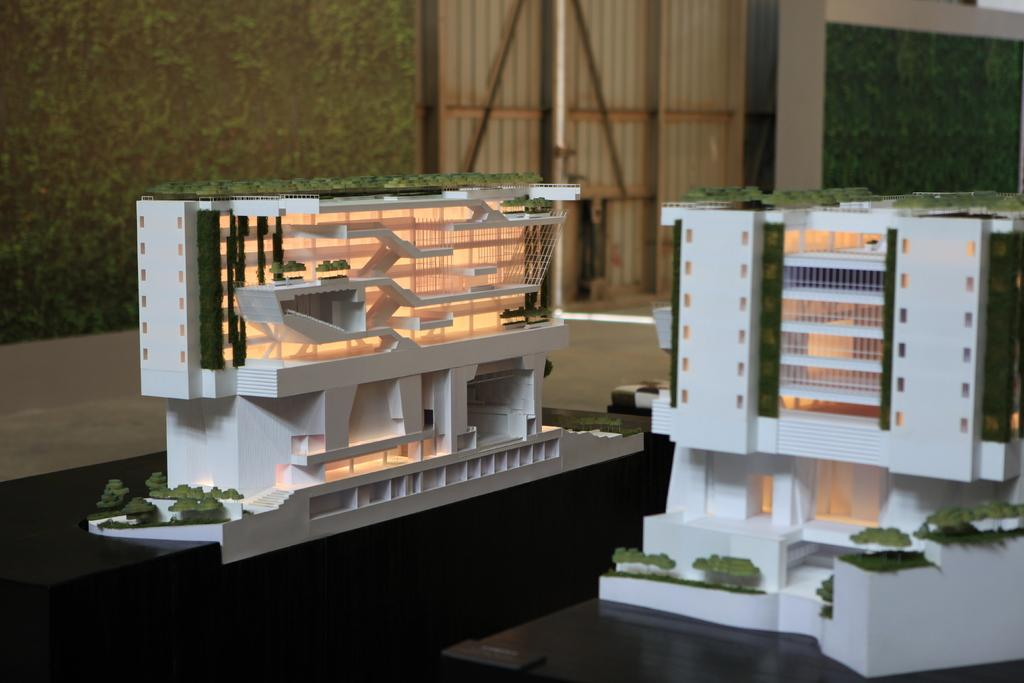What is the main subject of the image? The main subject of the image is a blueprint of buildings. Where is the blueprint located? The blueprint is placed on a table. What can be seen in the background of the image? There is a window and a wall in the background of the image. Can you tell me which face is depicted on the blueprint? There are no faces depicted on the blueprint; it is a technical drawing of buildings. 